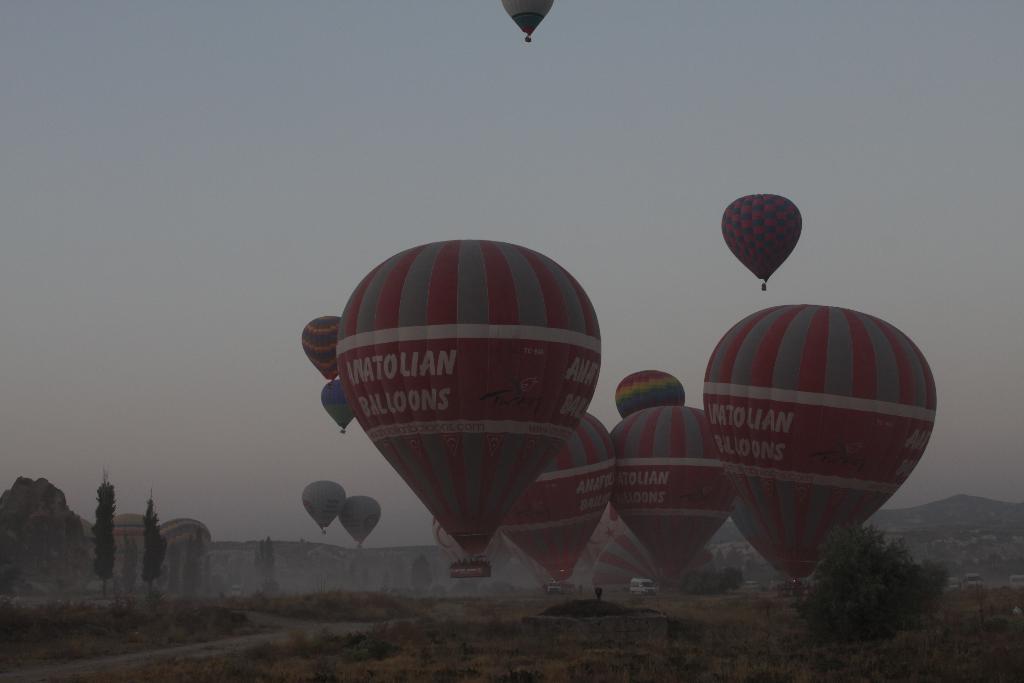Could you give a brief overview of what you see in this image? In the image we can see some parachutes. Behind the parachute there are some trees and vehicles. At the top of the image there is sky. 